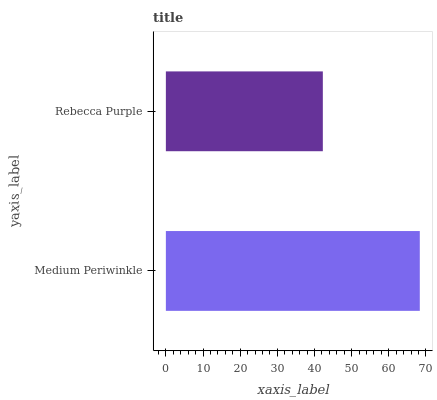Is Rebecca Purple the minimum?
Answer yes or no. Yes. Is Medium Periwinkle the maximum?
Answer yes or no. Yes. Is Rebecca Purple the maximum?
Answer yes or no. No. Is Medium Periwinkle greater than Rebecca Purple?
Answer yes or no. Yes. Is Rebecca Purple less than Medium Periwinkle?
Answer yes or no. Yes. Is Rebecca Purple greater than Medium Periwinkle?
Answer yes or no. No. Is Medium Periwinkle less than Rebecca Purple?
Answer yes or no. No. Is Medium Periwinkle the high median?
Answer yes or no. Yes. Is Rebecca Purple the low median?
Answer yes or no. Yes. Is Rebecca Purple the high median?
Answer yes or no. No. Is Medium Periwinkle the low median?
Answer yes or no. No. 